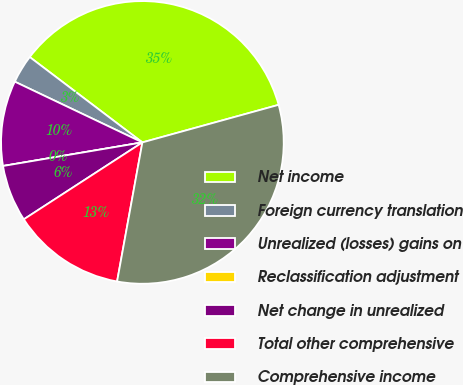Convert chart. <chart><loc_0><loc_0><loc_500><loc_500><pie_chart><fcel>Net income<fcel>Foreign currency translation<fcel>Unrealized (losses) gains on<fcel>Reclassification adjustment<fcel>Net change in unrealized<fcel>Total other comprehensive<fcel>Comprehensive income<nl><fcel>35.4%<fcel>3.25%<fcel>9.74%<fcel>0.0%<fcel>6.49%<fcel>12.98%<fcel>32.15%<nl></chart> 